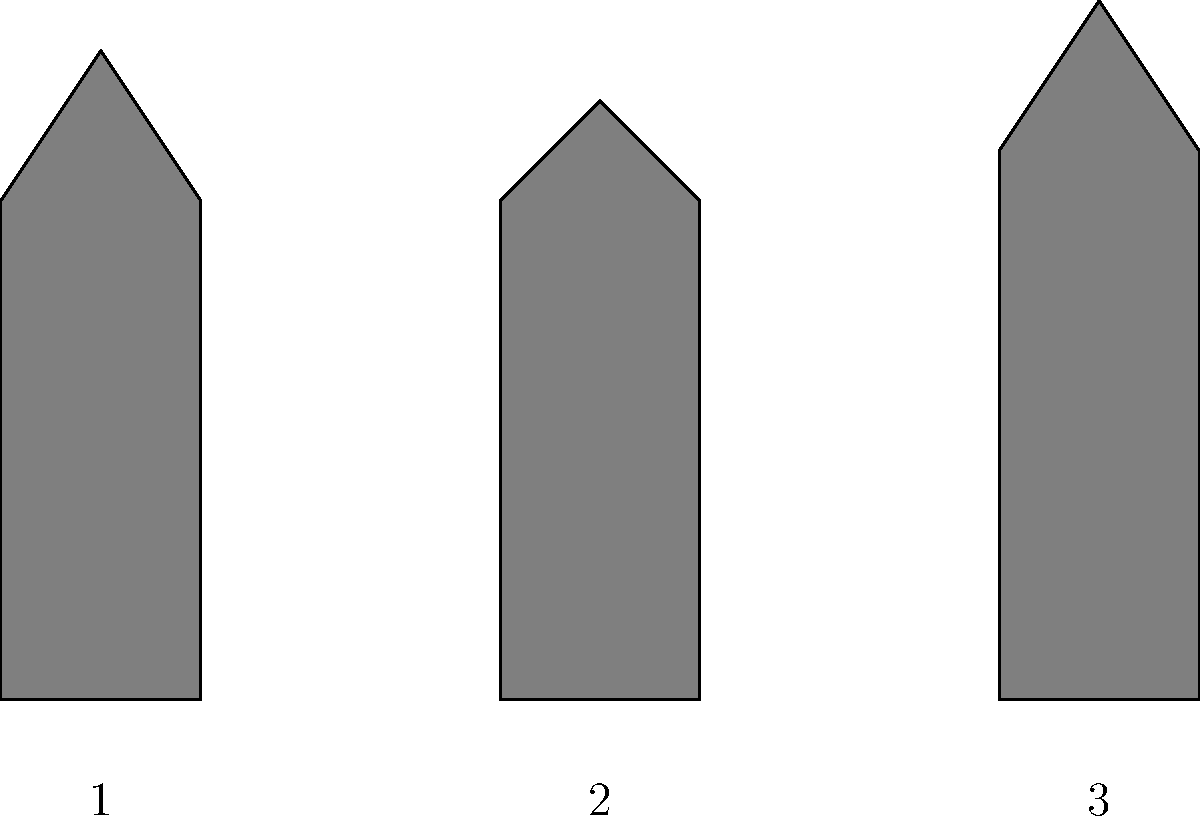Identify the Love Live! character represented by silhouette number 2. To identify the character represented by silhouette number 2, let's analyze the characteristics of each silhouette:

1. Silhouette 1 (left): This figure has a distinctive hairstyle with two side parts, likely representing Umi Sonoda.
2. Silhouette 2 (center): This figure has a rounder head shape with a small bump on top, indicating a short side ponytail. This is characteristic of Honoka Kousaka, the main protagonist of Love Live!
3. Silhouette 3 (right): This figure has a taller silhouette with a distinctive hairstyle that appears to be longer and possibly tied back, which is typical of Kotori Minami.

Based on these observations, we can conclude that silhouette number 2 represents Honoka Kousaka, known for her energetic personality and leadership role in μ's.
Answer: Honoka Kousaka 